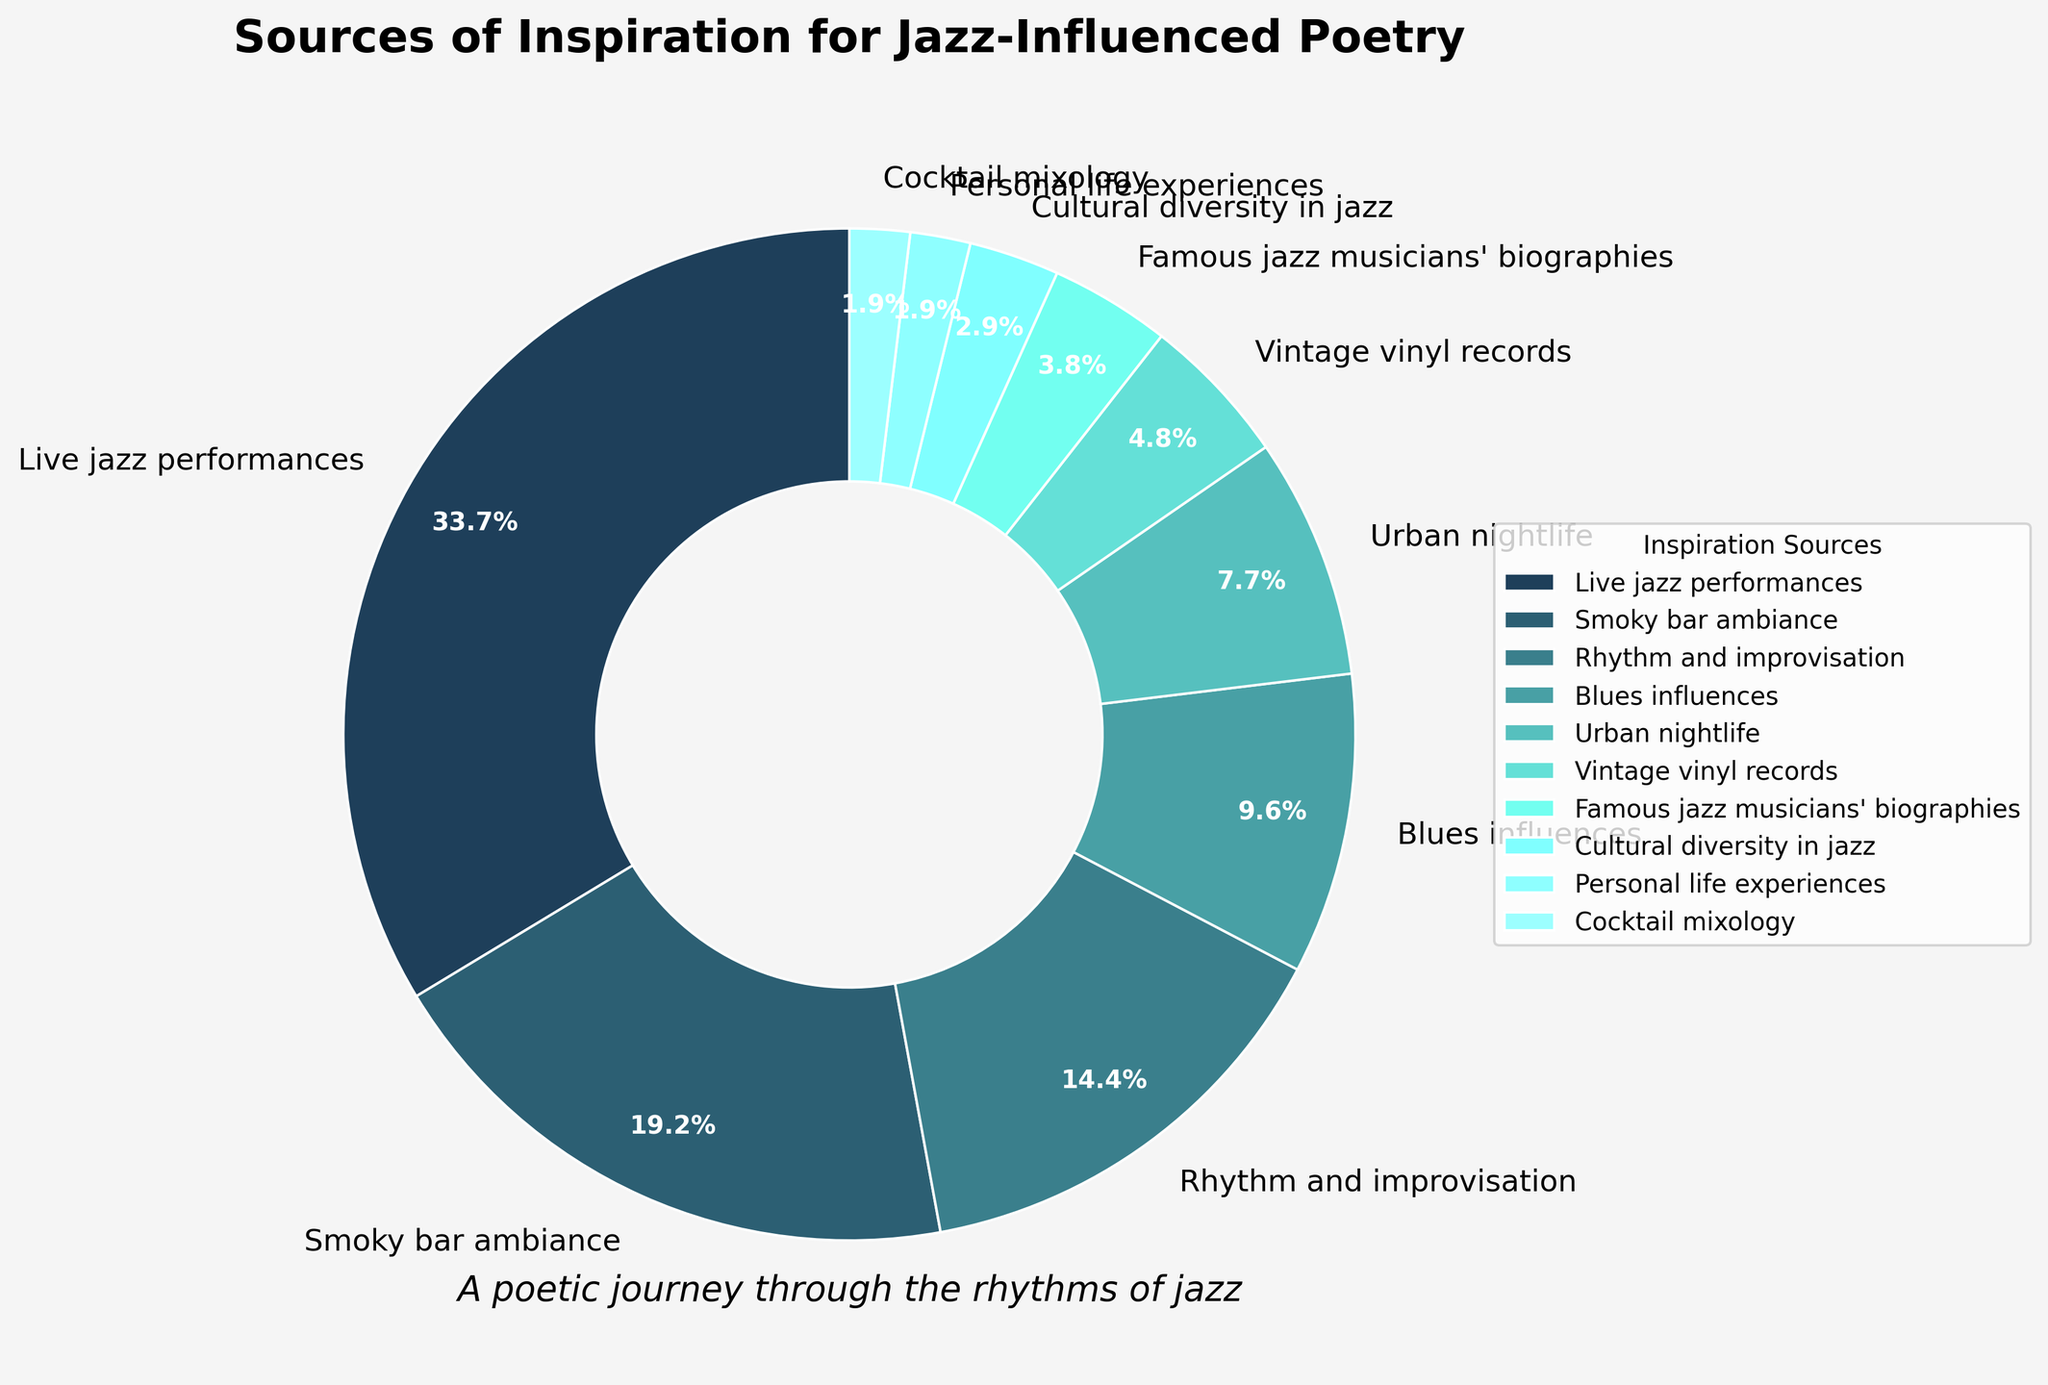What source of inspiration has the highest percentage? Identify the wedge that occupies the largest area and read its corresponding label. "Live jazz performances" has the highest percentage of 35%.
Answer: Live jazz performances Which sources of inspiration combined account for more than 50%? Add the percentages of the sources starting from the highest until the total exceeds 50%. Adding "Live jazz performances" (35%) and "Smoky bar ambiance" (20%) equals 55%, which is more than 50%.
Answer: Live jazz performances and Smoky bar ambiance By how much does the percentage of "Rhythm and improvisation" exceed "Blues influences"? Subtract the percentage of "Blues influences" from that of "Rhythm and improvisation". 15% - 10% = 5%.
Answer: 5% What is the combined percentage for the sources that are inspired by physical objects or things? Add the percentages of "Vintage vinyl records" (5%) and "Cocktail mixology" (2%). 5% + 2% = 7%.
Answer: 7% How does the percentage of "Urban nightlife" compare to "Smoky bar ambiance"? Compare the percentages directly. "Urban nightlife" has 8%, and "Smoky bar ambiance" has 20%, so 8% is less than 20%.
Answer: Less than What color represents the largest wedge in the pie chart? Identify the wedge with the largest area and note its color. The largest wedge, representing "Live jazz performances", is dark blue.
Answer: Dark blue Which sources of inspiration have the lowest and highest percentages, respectively? Identify the smallest and largest percentages and their corresponding labels. The lowest is "Cocktail mixology" at 2%; the highest is "Live jazz performances" at 35%.
Answer: Cocktail mixology and Live jazz performances Which source of inspiration is closest in percentage to the average percentage of all sources? First, calculate the average percentage by summing all percentages and dividing by the number of sources: (35 + 20 + 15 + 10 + 8 + 5 + 4 + 3 + 2 + 2) / 10 = 10.4%. Compare with the given percentages to find the closest value, which is "Blues influences" at 10%.
Answer: Blues influences If you combined "Personal life experiences" and "Cocktail mixology", what would their total percentage be, and how would it compare to "Urban nightlife"? Add the percentages of "Personal life experiences" (2%) and "Cocktail mixology" (2%) to get 4%. Compare this total to "Urban nightlife" (8%). 4% is less than 8%.
Answer: 4%, less than What are the combined percentages of all sources related to music? Add the percentages of "Live jazz performances" (35%), "Rhythm and improvisation" (15%), "Blues influences" (10%), "Vintage vinyl records" (5%), and "Famous jazz musicians' biographies" (4%). 35 + 15 + 10 + 5 + 4 = 69%.
Answer: 69% 